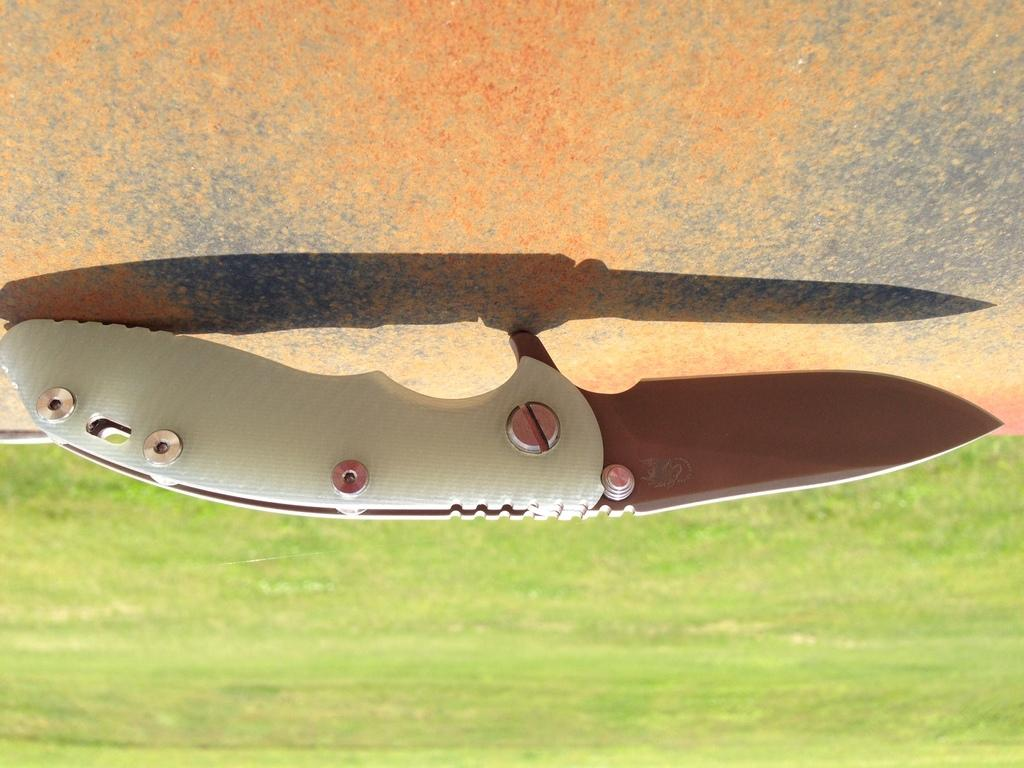What object is located in the center of the image? There is a knife in the center of the image. What color is the knife? The knife is white in color. What type of vegetation can be seen at the bottom of the image? There is grass visible at the bottom of the image. Can you give an example of a house in the image? There is no house present in the image; it only features a white knife and grass. 